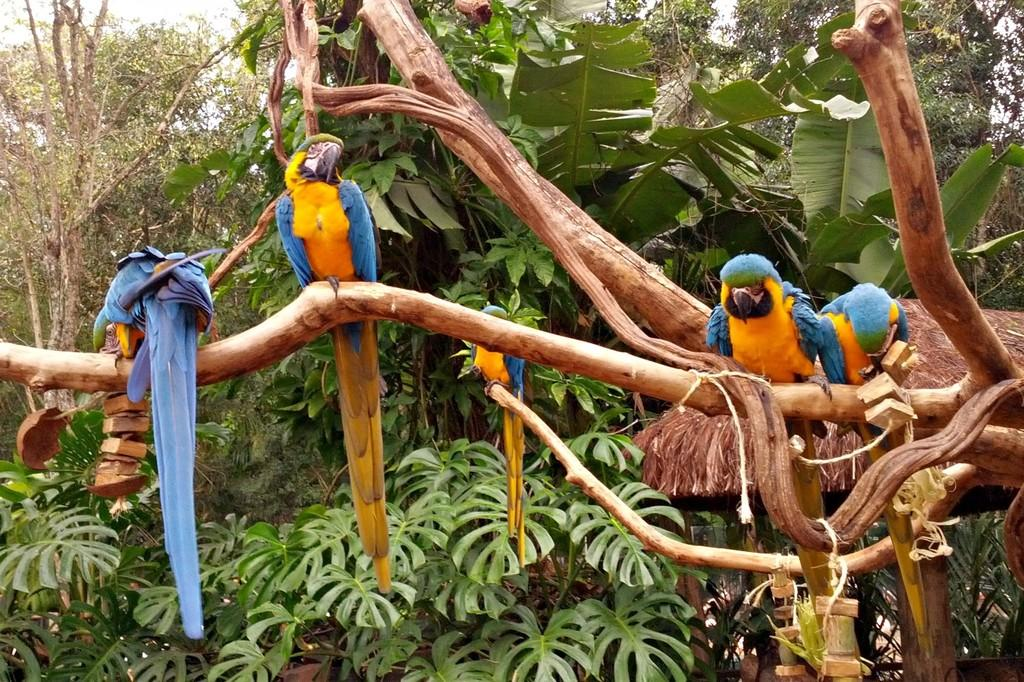How many parrots are in the image? There are five parrots in the image. What are the parrots standing on? The parrots are standing on a branch. What type of vegetation is present in the image? There are trees with branches and leaves in the image. What time does the clock show in the image? There are no clocks present in the image. 